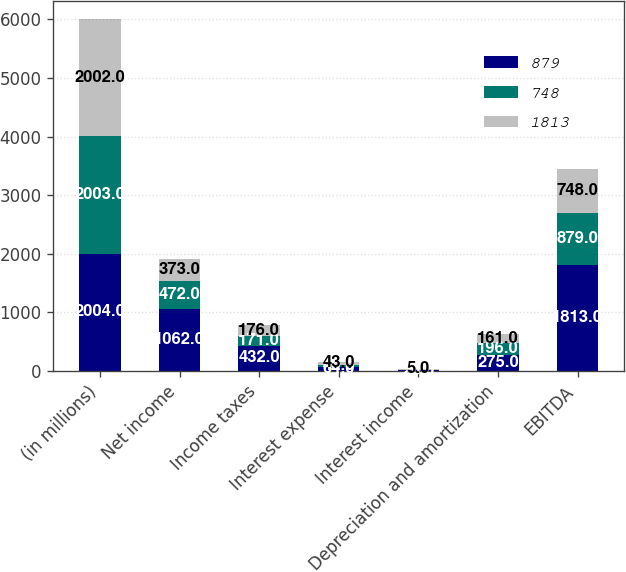Convert chart to OTSL. <chart><loc_0><loc_0><loc_500><loc_500><stacked_bar_chart><ecel><fcel>(in millions)<fcel>Net income<fcel>Income taxes<fcel>Interest expense<fcel>Interest income<fcel>Depreciation and amortization<fcel>EBITDA<nl><fcel>879<fcel>2004<fcel>1062<fcel>432<fcel>64<fcel>20<fcel>275<fcel>1813<nl><fcel>748<fcel>2003<fcel>472<fcel>171<fcel>46<fcel>6<fcel>196<fcel>879<nl><fcel>1813<fcel>2002<fcel>373<fcel>176<fcel>43<fcel>5<fcel>161<fcel>748<nl></chart> 